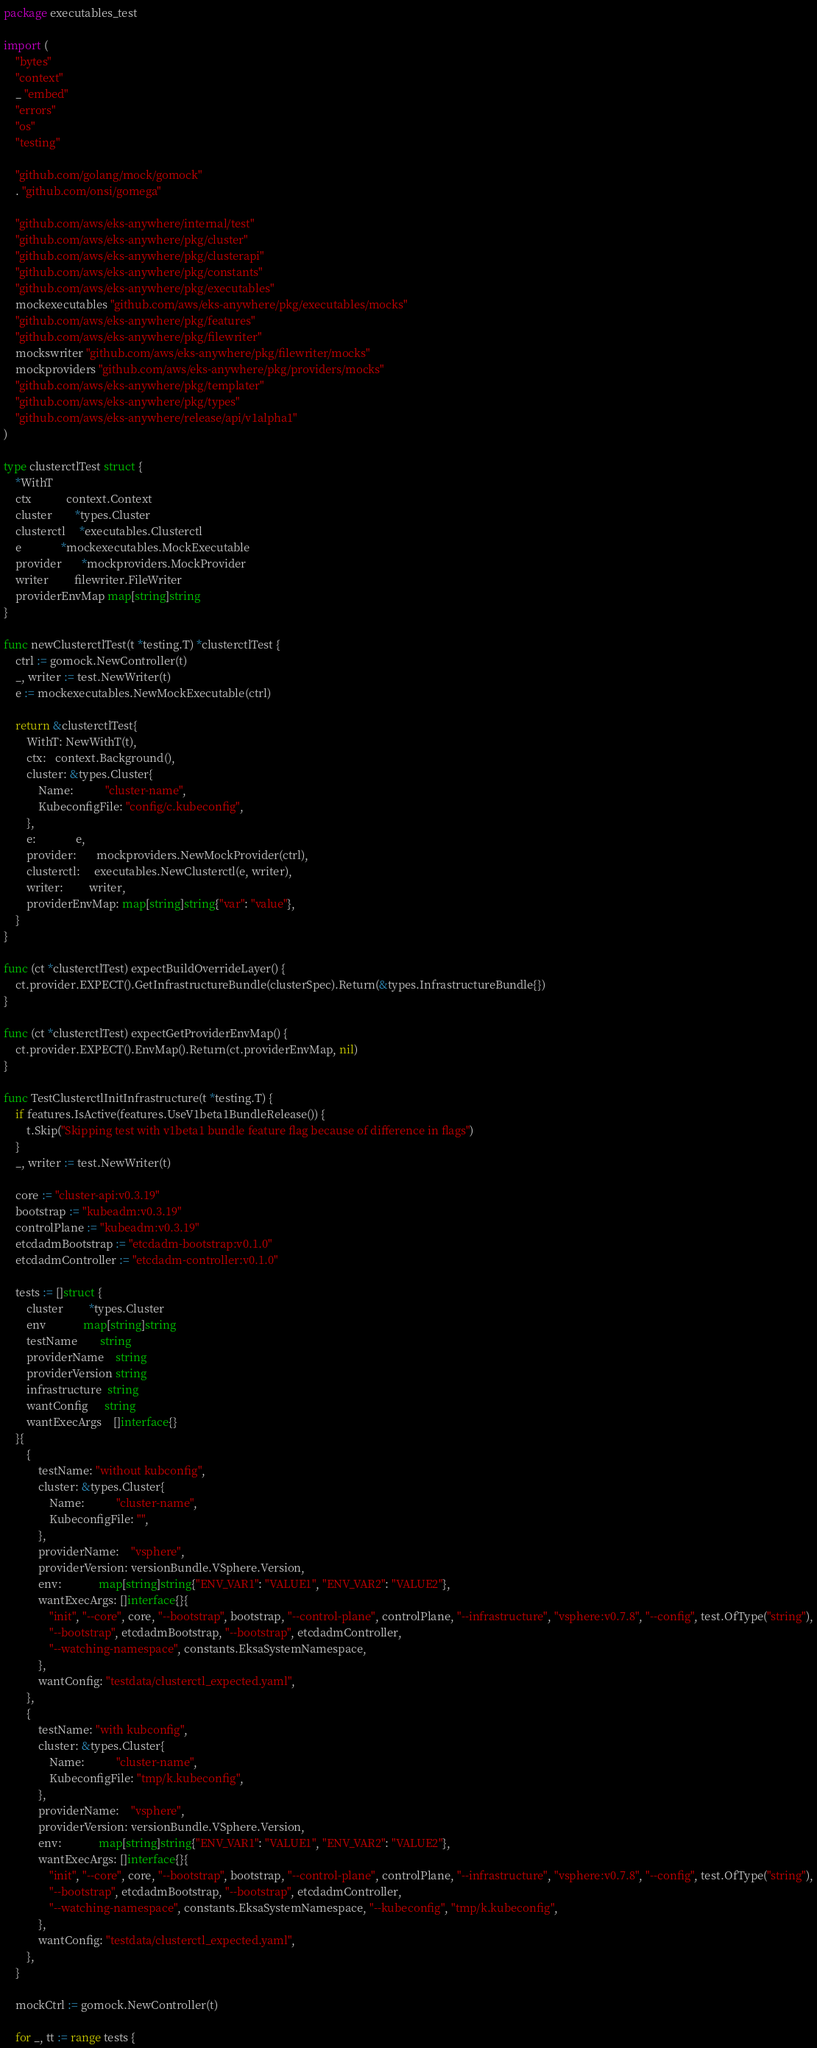<code> <loc_0><loc_0><loc_500><loc_500><_Go_>package executables_test

import (
	"bytes"
	"context"
	_ "embed"
	"errors"
	"os"
	"testing"

	"github.com/golang/mock/gomock"
	. "github.com/onsi/gomega"

	"github.com/aws/eks-anywhere/internal/test"
	"github.com/aws/eks-anywhere/pkg/cluster"
	"github.com/aws/eks-anywhere/pkg/clusterapi"
	"github.com/aws/eks-anywhere/pkg/constants"
	"github.com/aws/eks-anywhere/pkg/executables"
	mockexecutables "github.com/aws/eks-anywhere/pkg/executables/mocks"
	"github.com/aws/eks-anywhere/pkg/features"
	"github.com/aws/eks-anywhere/pkg/filewriter"
	mockswriter "github.com/aws/eks-anywhere/pkg/filewriter/mocks"
	mockproviders "github.com/aws/eks-anywhere/pkg/providers/mocks"
	"github.com/aws/eks-anywhere/pkg/templater"
	"github.com/aws/eks-anywhere/pkg/types"
	"github.com/aws/eks-anywhere/release/api/v1alpha1"
)

type clusterctlTest struct {
	*WithT
	ctx            context.Context
	cluster        *types.Cluster
	clusterctl     *executables.Clusterctl
	e              *mockexecutables.MockExecutable
	provider       *mockproviders.MockProvider
	writer         filewriter.FileWriter
	providerEnvMap map[string]string
}

func newClusterctlTest(t *testing.T) *clusterctlTest {
	ctrl := gomock.NewController(t)
	_, writer := test.NewWriter(t)
	e := mockexecutables.NewMockExecutable(ctrl)

	return &clusterctlTest{
		WithT: NewWithT(t),
		ctx:   context.Background(),
		cluster: &types.Cluster{
			Name:           "cluster-name",
			KubeconfigFile: "config/c.kubeconfig",
		},
		e:              e,
		provider:       mockproviders.NewMockProvider(ctrl),
		clusterctl:     executables.NewClusterctl(e, writer),
		writer:         writer,
		providerEnvMap: map[string]string{"var": "value"},
	}
}

func (ct *clusterctlTest) expectBuildOverrideLayer() {
	ct.provider.EXPECT().GetInfrastructureBundle(clusterSpec).Return(&types.InfrastructureBundle{})
}

func (ct *clusterctlTest) expectGetProviderEnvMap() {
	ct.provider.EXPECT().EnvMap().Return(ct.providerEnvMap, nil)
}

func TestClusterctlInitInfrastructure(t *testing.T) {
	if features.IsActive(features.UseV1beta1BundleRelease()) {
		t.Skip("Skipping test with v1beta1 bundle feature flag because of difference in flags")
	}
	_, writer := test.NewWriter(t)

	core := "cluster-api:v0.3.19"
	bootstrap := "kubeadm:v0.3.19"
	controlPlane := "kubeadm:v0.3.19"
	etcdadmBootstrap := "etcdadm-bootstrap:v0.1.0"
	etcdadmController := "etcdadm-controller:v0.1.0"

	tests := []struct {
		cluster         *types.Cluster
		env             map[string]string
		testName        string
		providerName    string
		providerVersion string
		infrastructure  string
		wantConfig      string
		wantExecArgs    []interface{}
	}{
		{
			testName: "without kubconfig",
			cluster: &types.Cluster{
				Name:           "cluster-name",
				KubeconfigFile: "",
			},
			providerName:    "vsphere",
			providerVersion: versionBundle.VSphere.Version,
			env:             map[string]string{"ENV_VAR1": "VALUE1", "ENV_VAR2": "VALUE2"},
			wantExecArgs: []interface{}{
				"init", "--core", core, "--bootstrap", bootstrap, "--control-plane", controlPlane, "--infrastructure", "vsphere:v0.7.8", "--config", test.OfType("string"),
				"--bootstrap", etcdadmBootstrap, "--bootstrap", etcdadmController,
				"--watching-namespace", constants.EksaSystemNamespace,
			},
			wantConfig: "testdata/clusterctl_expected.yaml",
		},
		{
			testName: "with kubconfig",
			cluster: &types.Cluster{
				Name:           "cluster-name",
				KubeconfigFile: "tmp/k.kubeconfig",
			},
			providerName:    "vsphere",
			providerVersion: versionBundle.VSphere.Version,
			env:             map[string]string{"ENV_VAR1": "VALUE1", "ENV_VAR2": "VALUE2"},
			wantExecArgs: []interface{}{
				"init", "--core", core, "--bootstrap", bootstrap, "--control-plane", controlPlane, "--infrastructure", "vsphere:v0.7.8", "--config", test.OfType("string"),
				"--bootstrap", etcdadmBootstrap, "--bootstrap", etcdadmController,
				"--watching-namespace", constants.EksaSystemNamespace, "--kubeconfig", "tmp/k.kubeconfig",
			},
			wantConfig: "testdata/clusterctl_expected.yaml",
		},
	}

	mockCtrl := gomock.NewController(t)

	for _, tt := range tests {</code> 